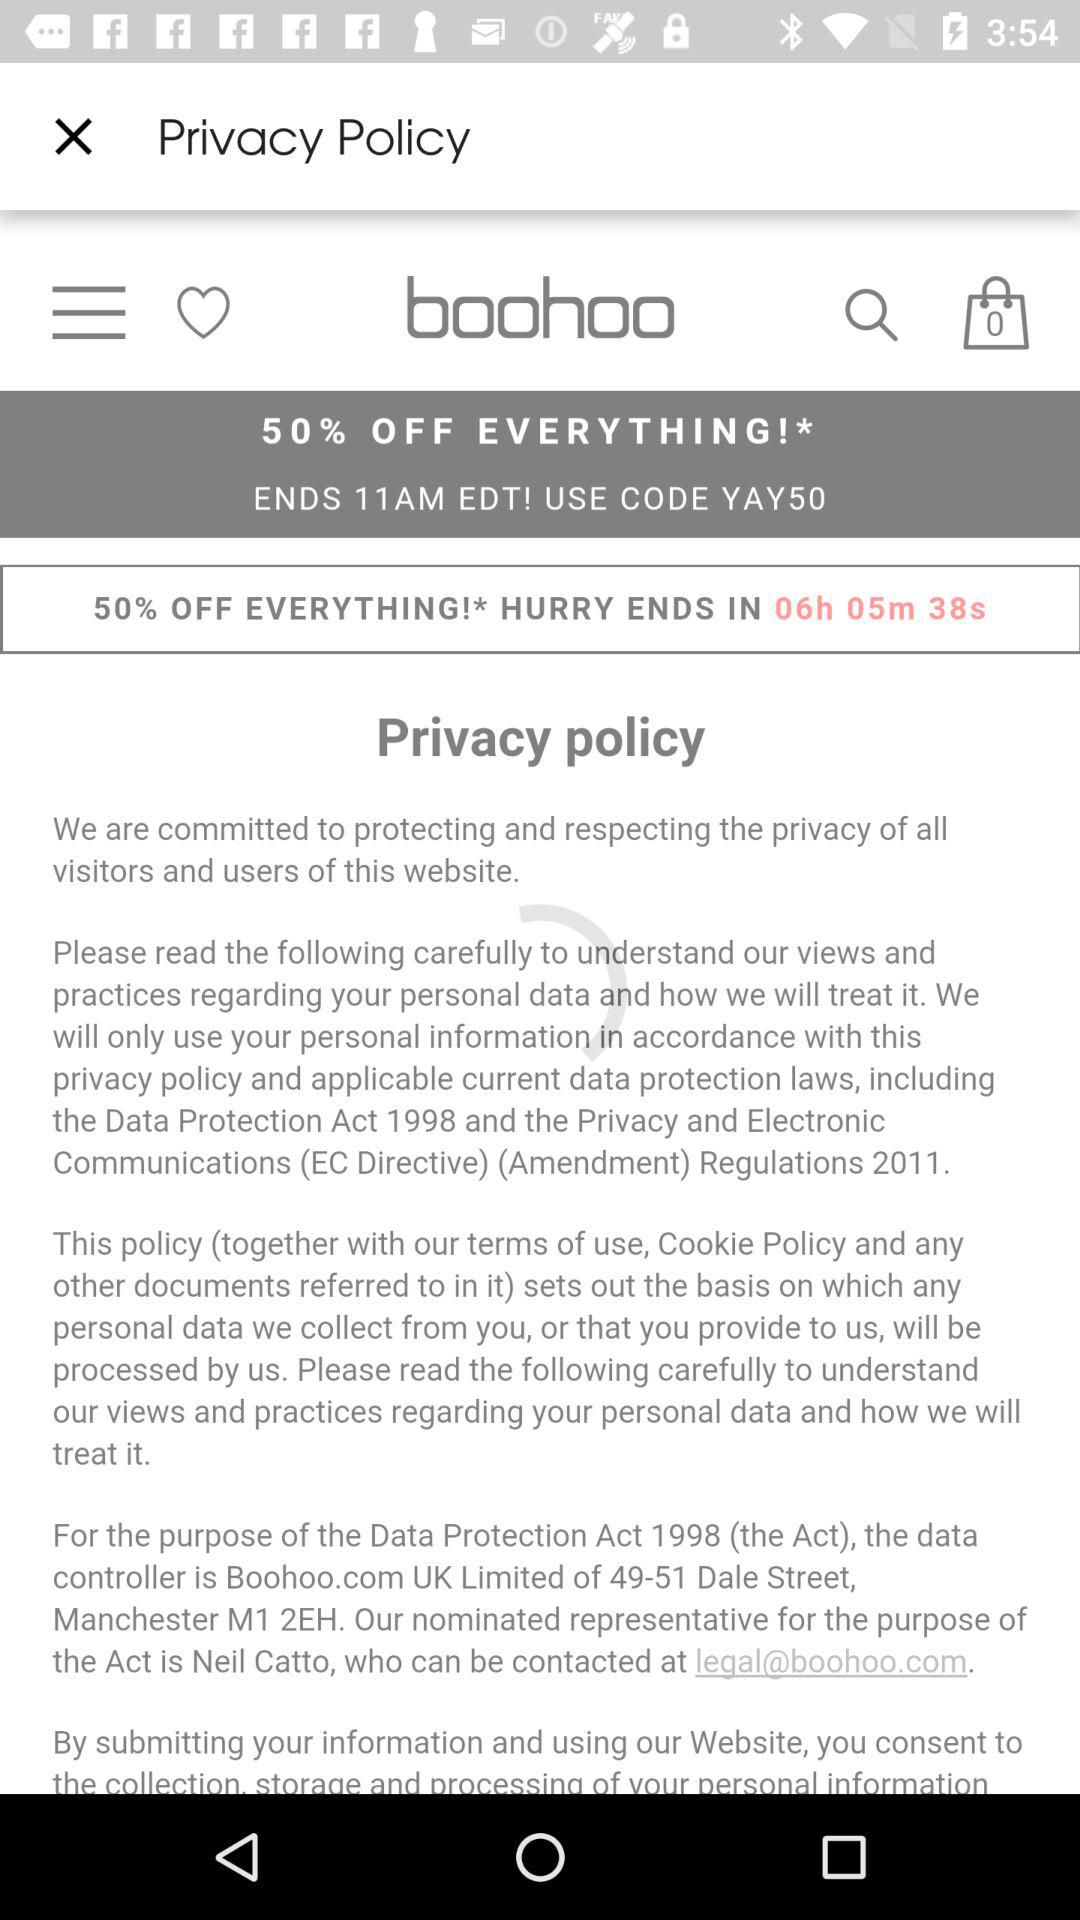What is the percentage of the sale?
When the provided information is insufficient, respond with <no answer>. <no answer> 